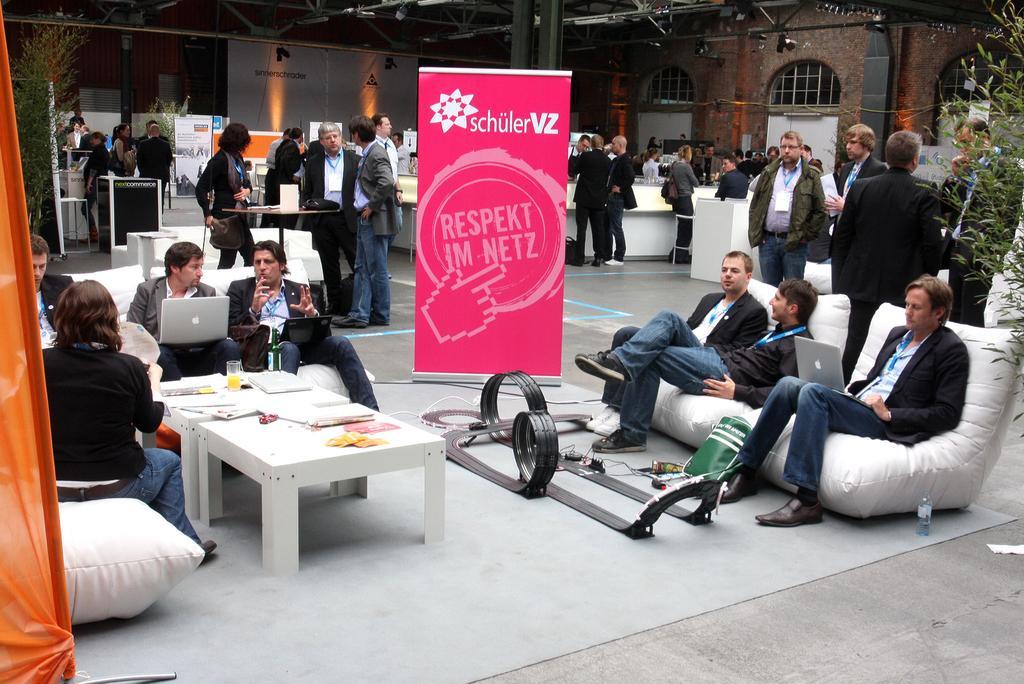How would you summarize this image in a sentence or two? There is a group of people. Some persons are sitting on a chairs and some persons are standing. They are wearing a is a cards. Some persons are holding a laptops. There is a table on the left side. There is a papers on a table. We can see in the background building with red color wall brick ,plants and curtain. 